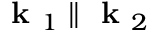Convert formula to latex. <formula><loc_0><loc_0><loc_500><loc_500>k _ { 1 } \| k _ { 2 }</formula> 